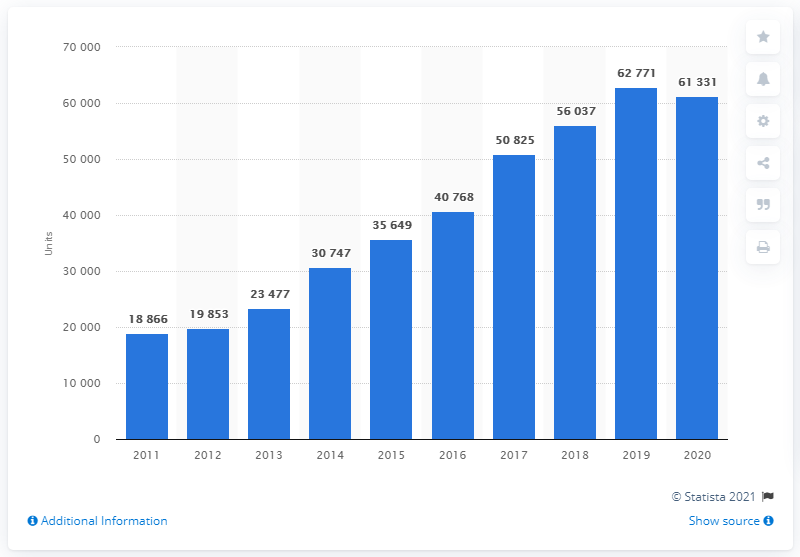Specify some key components in this picture. In the year 2011, a total of 18,866 Toyota cars were registered in Poland. In 2020, a total of 61,331 new Toyota cars were registered in Poland. 